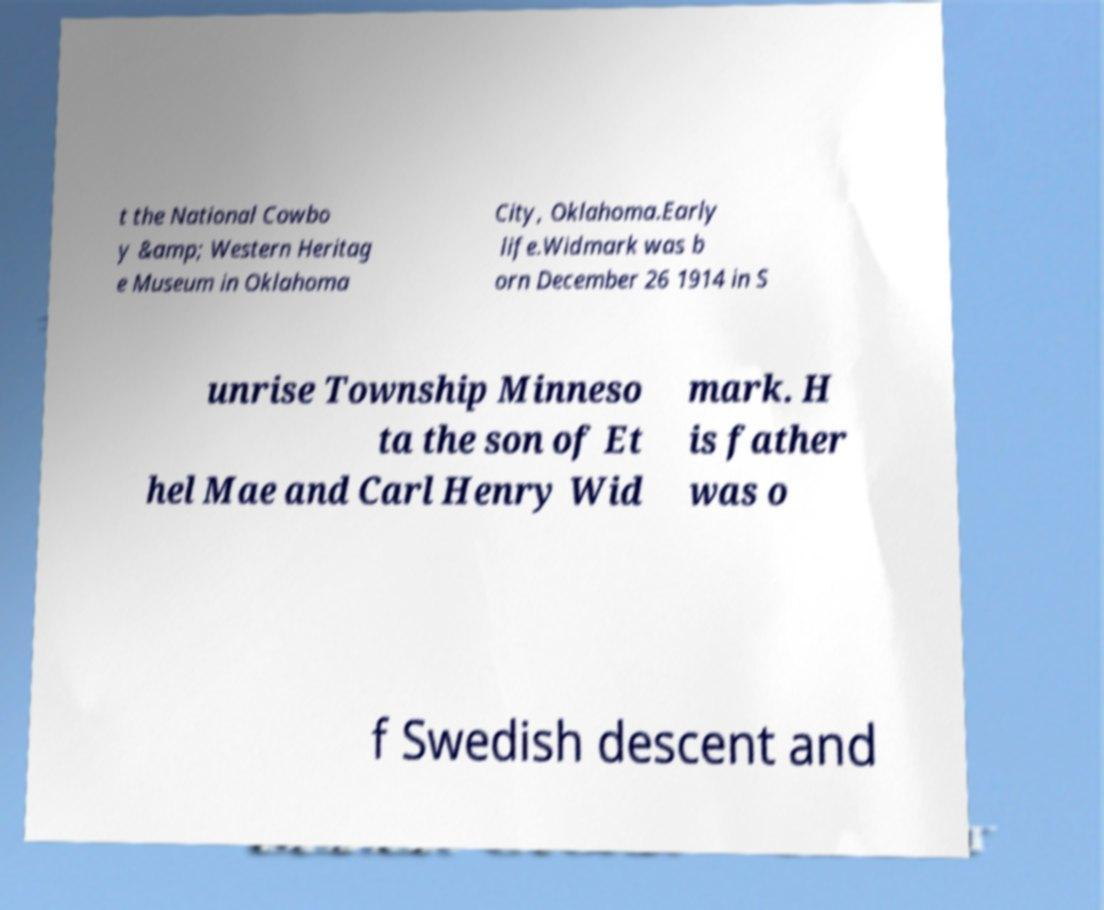Can you accurately transcribe the text from the provided image for me? t the National Cowbo y &amp; Western Heritag e Museum in Oklahoma City, Oklahoma.Early life.Widmark was b orn December 26 1914 in S unrise Township Minneso ta the son of Et hel Mae and Carl Henry Wid mark. H is father was o f Swedish descent and 